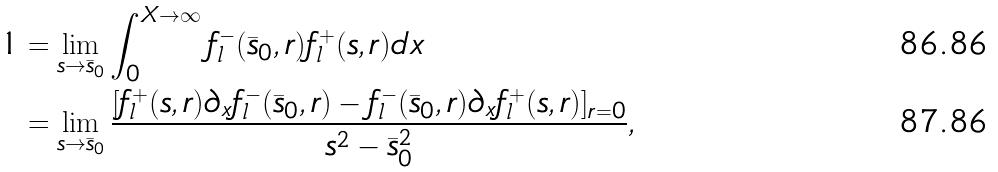Convert formula to latex. <formula><loc_0><loc_0><loc_500><loc_500>1 & = \lim _ { s \to \bar { s } _ { 0 } } \int _ { 0 } ^ { X \to \infty } f _ { l } ^ { - } ( \bar { s } _ { 0 } , r ) f _ { l } ^ { + } ( s , r ) d x \\ & = \lim _ { s \to \bar { s } _ { 0 } } \frac { [ f _ { l } ^ { + } ( s , r ) \partial _ { x } f _ { l } ^ { - } ( \bar { s } _ { 0 } , r ) - f _ { l } ^ { - } ( \bar { s } _ { 0 } , r ) \partial _ { x } f _ { l } ^ { + } ( s , r ) ] _ { r = 0 } } { s ^ { 2 } - \bar { s } _ { 0 } ^ { 2 } } ,</formula> 